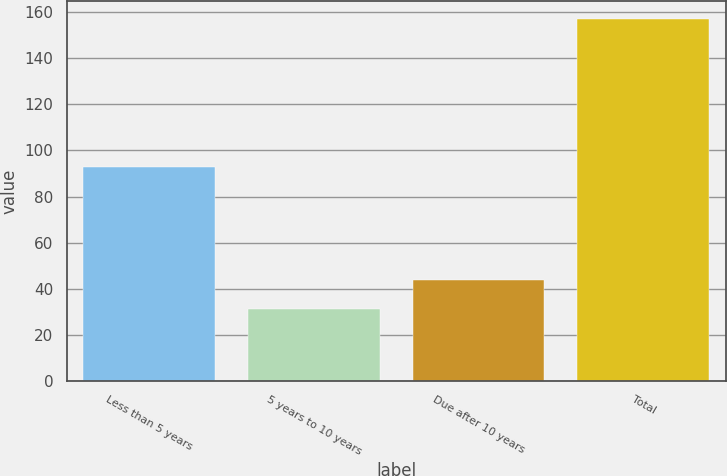<chart> <loc_0><loc_0><loc_500><loc_500><bar_chart><fcel>Less than 5 years<fcel>5 years to 10 years<fcel>Due after 10 years<fcel>Total<nl><fcel>93<fcel>31<fcel>43.6<fcel>157<nl></chart> 